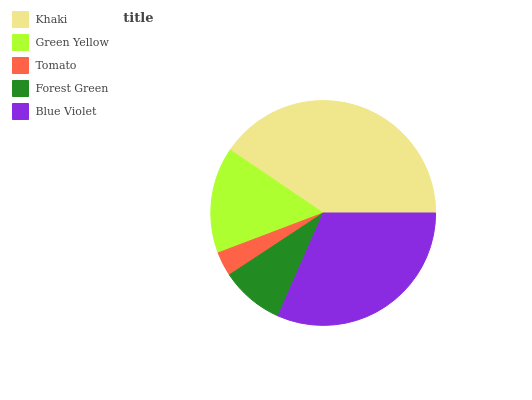Is Tomato the minimum?
Answer yes or no. Yes. Is Khaki the maximum?
Answer yes or no. Yes. Is Green Yellow the minimum?
Answer yes or no. No. Is Green Yellow the maximum?
Answer yes or no. No. Is Khaki greater than Green Yellow?
Answer yes or no. Yes. Is Green Yellow less than Khaki?
Answer yes or no. Yes. Is Green Yellow greater than Khaki?
Answer yes or no. No. Is Khaki less than Green Yellow?
Answer yes or no. No. Is Green Yellow the high median?
Answer yes or no. Yes. Is Green Yellow the low median?
Answer yes or no. Yes. Is Forest Green the high median?
Answer yes or no. No. Is Tomato the low median?
Answer yes or no. No. 